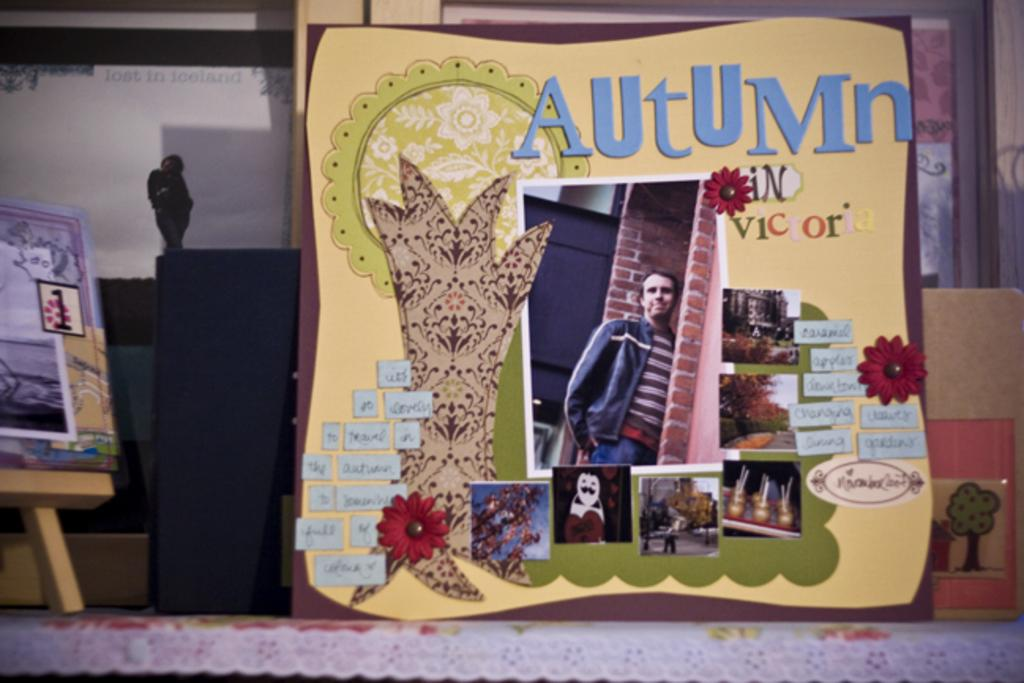<image>
Summarize the visual content of the image. The card talks about a particular season in a place called Victor. 